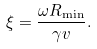Convert formula to latex. <formula><loc_0><loc_0><loc_500><loc_500>\xi = \frac { \omega R _ { \min } } { \gamma v } .</formula> 